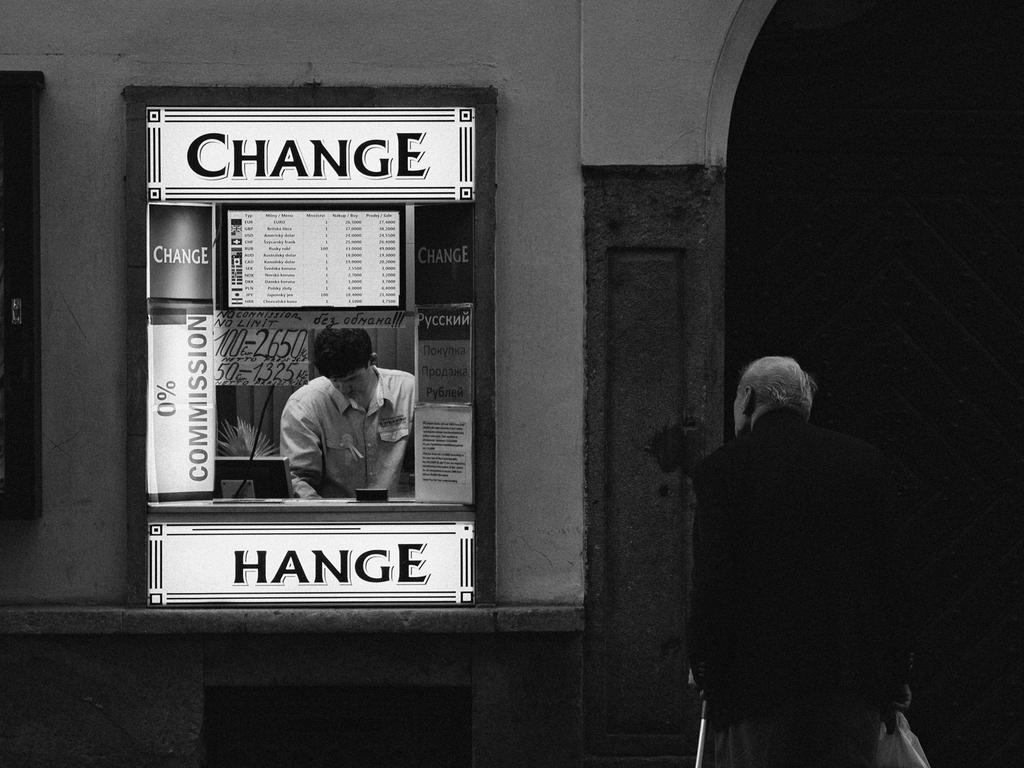What is on the wall in the image? There is an advertisement board on the wall in the image. What is the man in the image doing? The man is standing and watching in the image. What is the man holding in his hands? The man is holding a stick in one hand and a bag in the other hand. What is the man wearing? The man is wearing a black coat. Is the man wearing a hat in the image? There is no mention of a hat in the image, so we cannot determine if the man is wearing one. What type of instrument is the man playing in the image? There is no instrument present in the image; the man is holding a stick and a bag. 